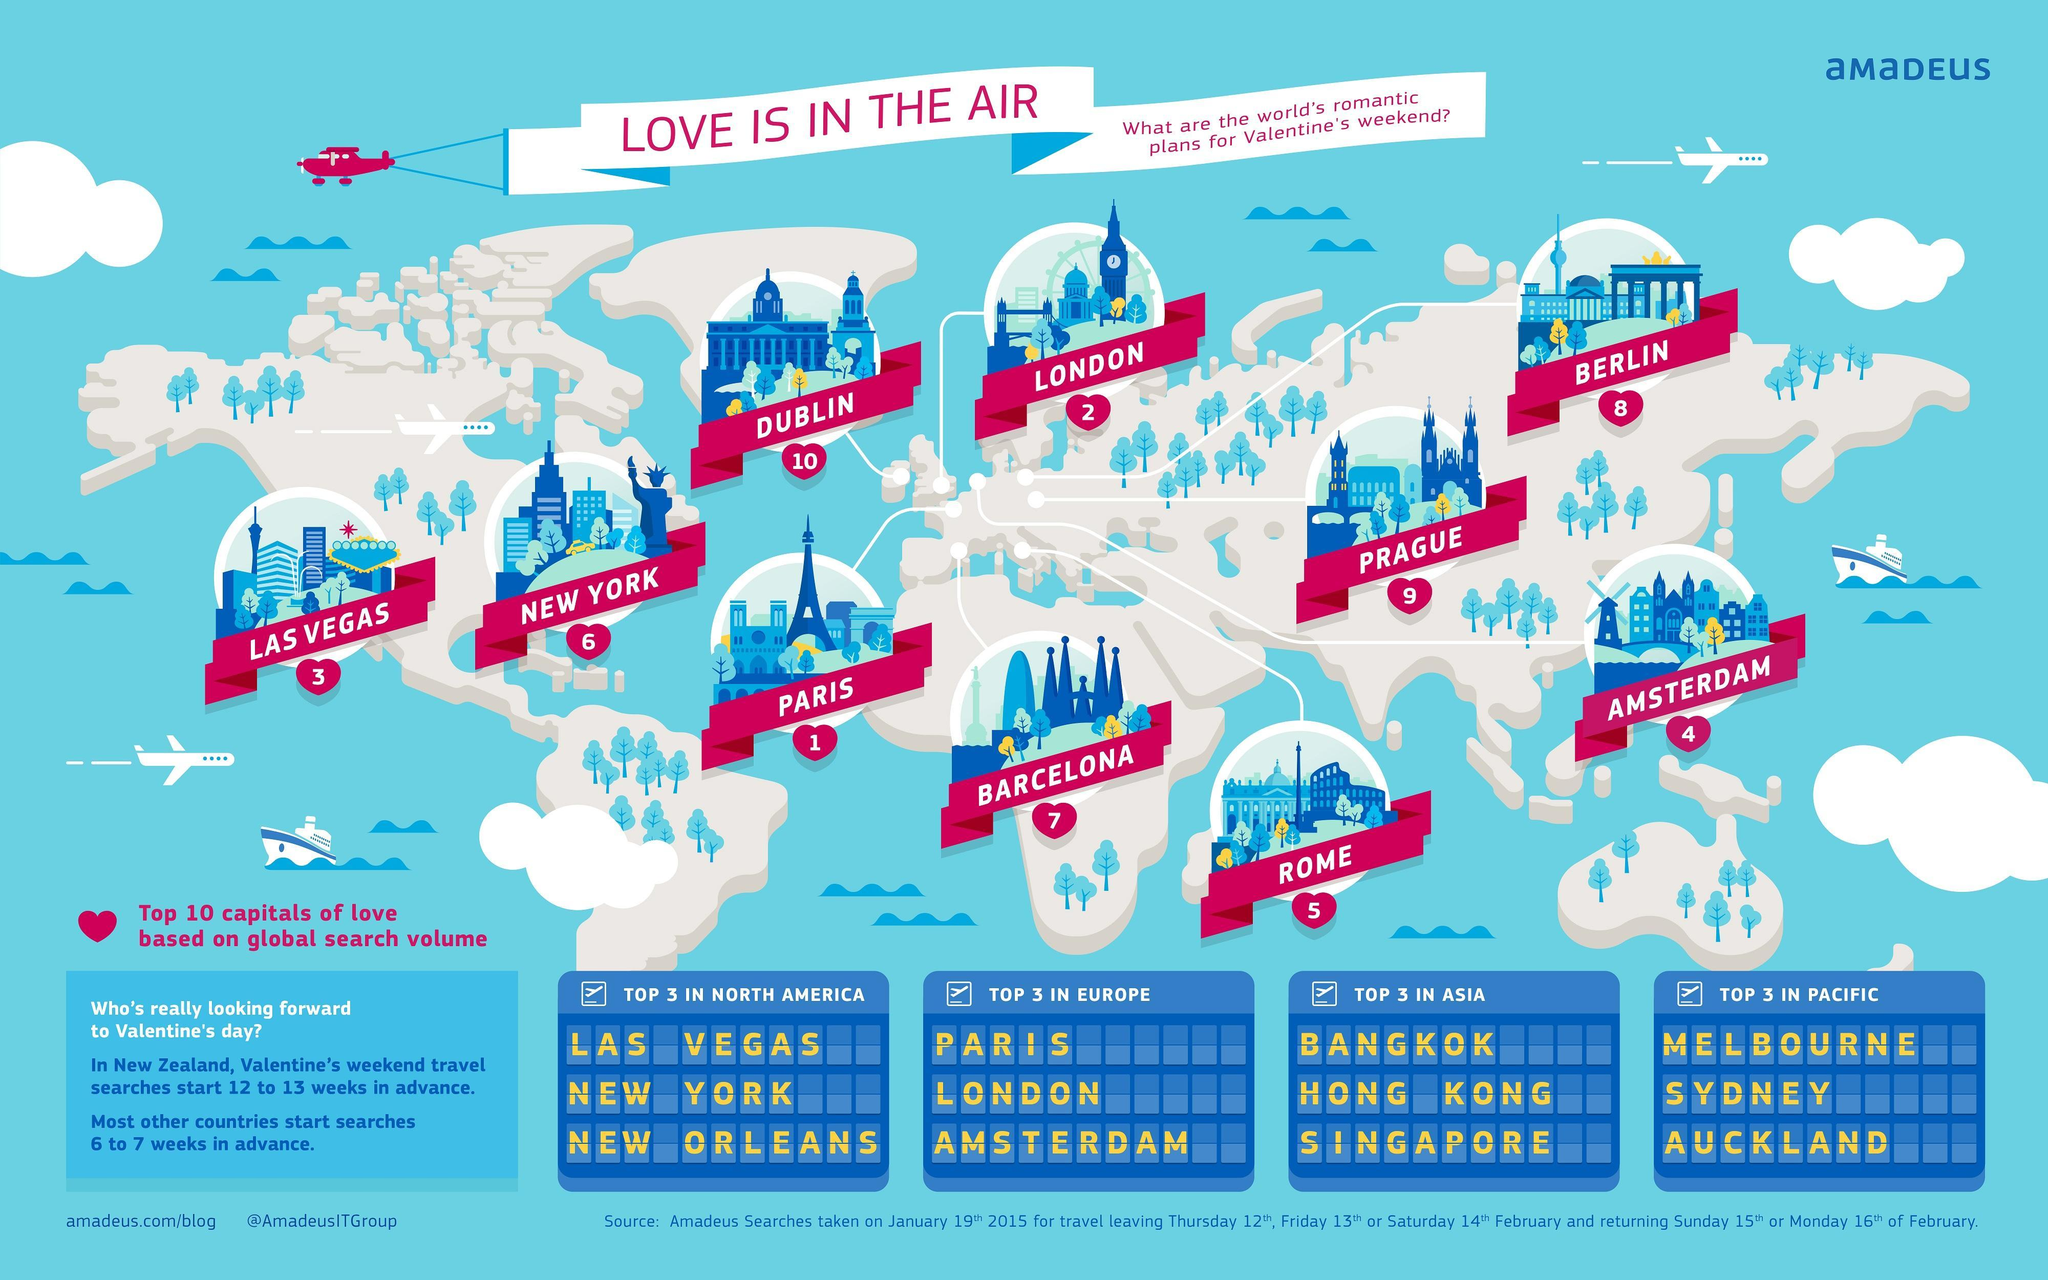Which are the top 3 places to visit in Oceania for Valentines day weekend?
Answer the question with a short phrase. Melbourne, Sydney, Auckland Which are the top 3 places to visit in Europe for Valentines day weekend? Paris, London, Amsterdam To which continent does most of cities in the top ten ranking belong to ? Europe Which  two cities belong to North American continent? Las Vegas, New York 